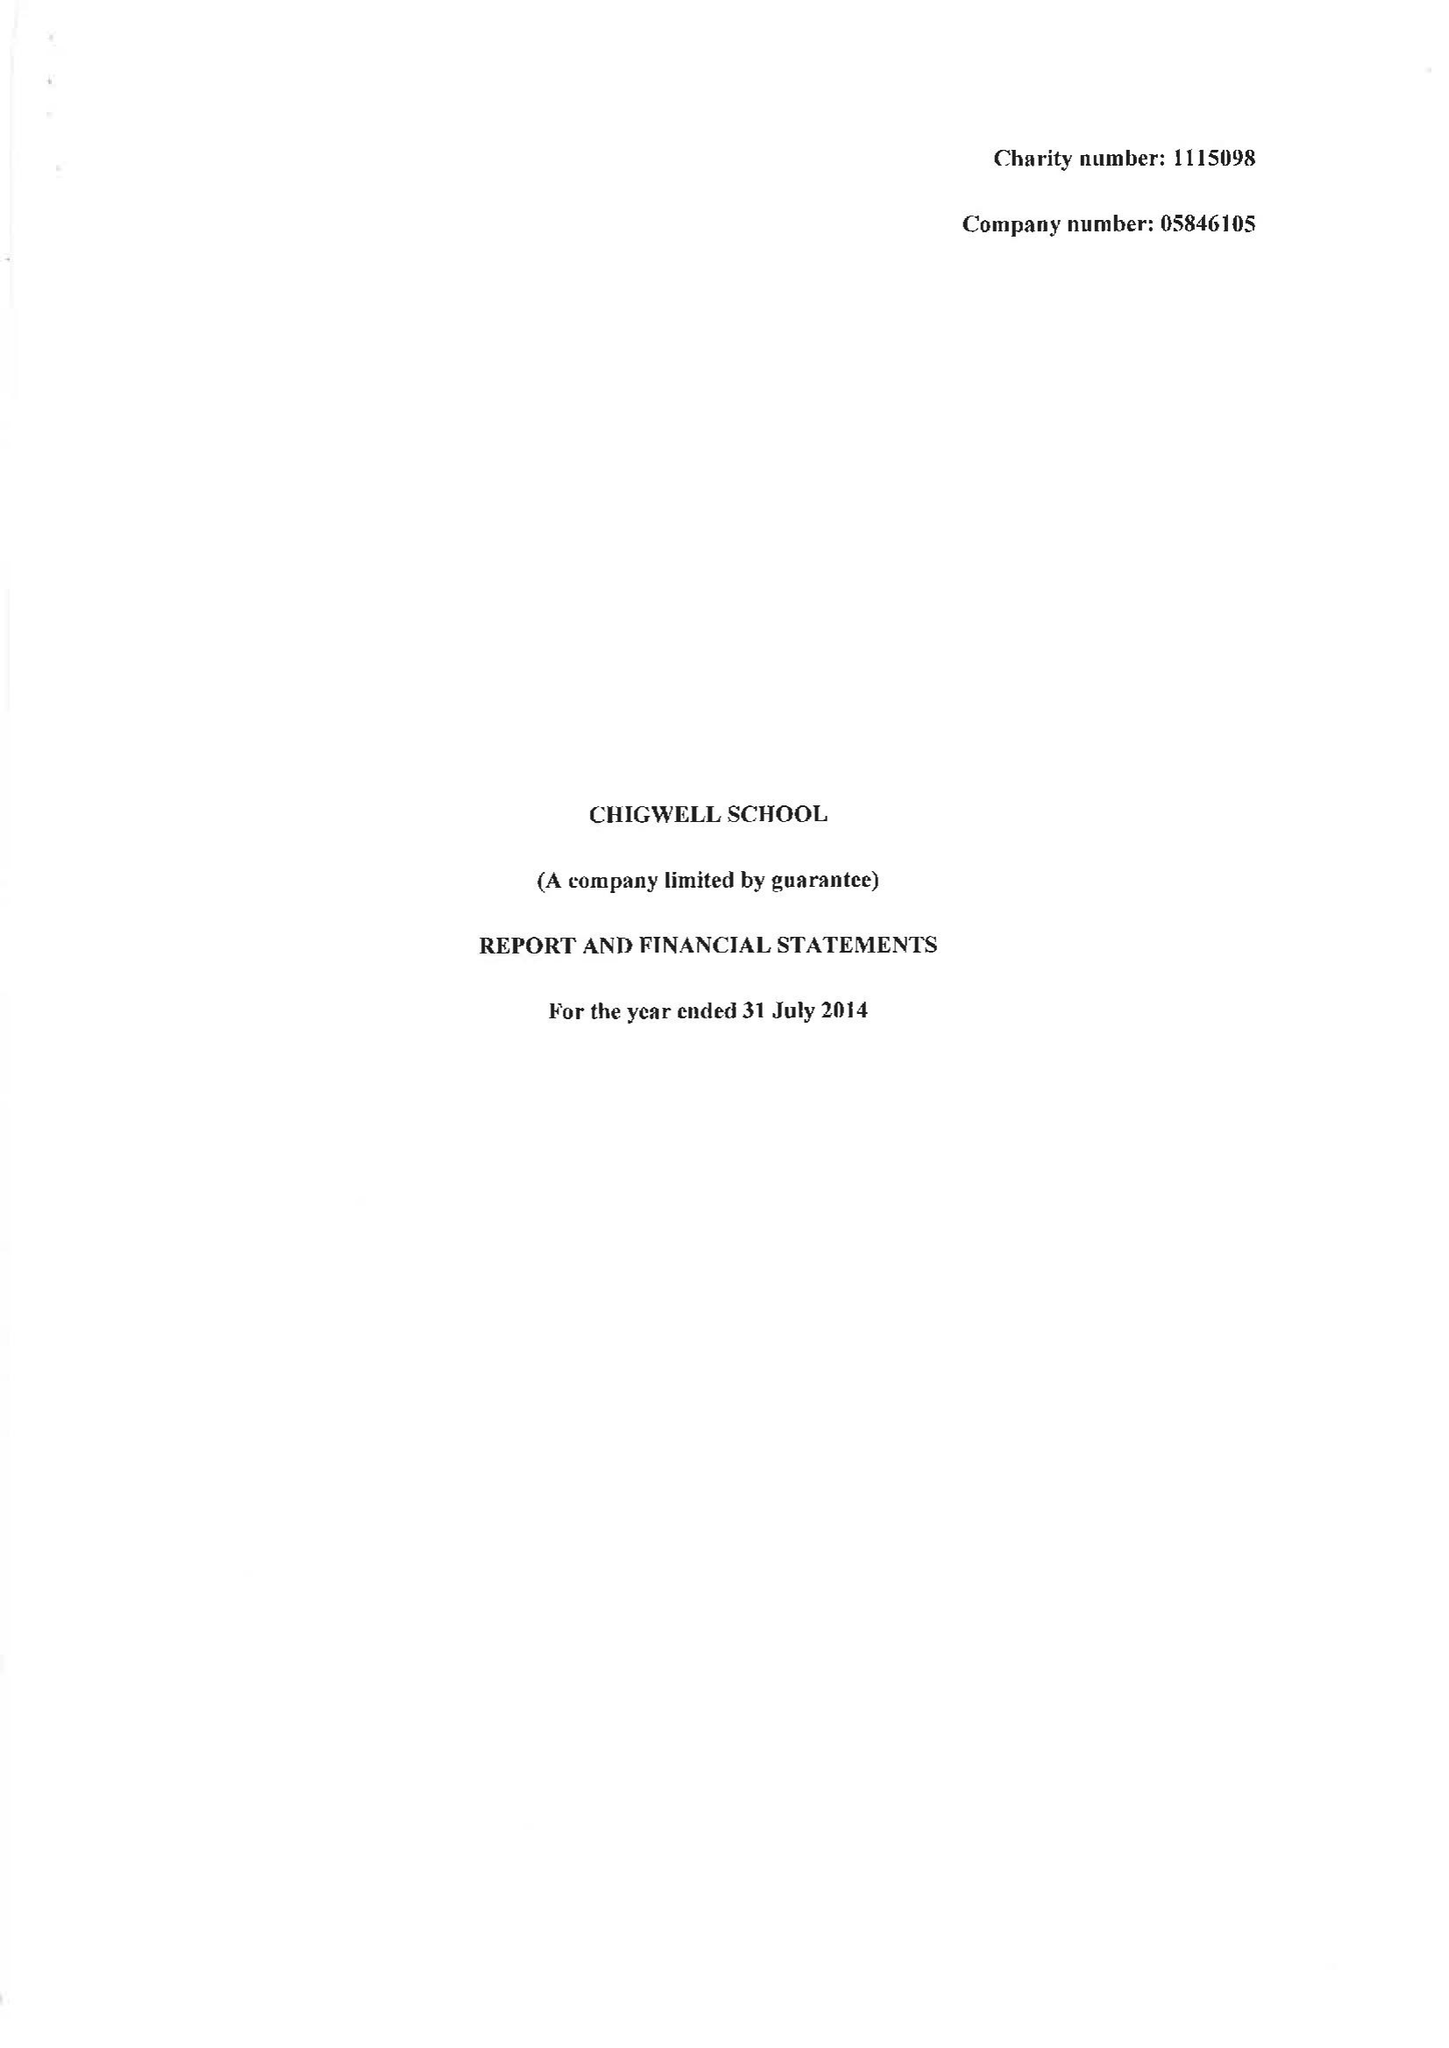What is the value for the income_annually_in_british_pounds?
Answer the question using a single word or phrase. 11946000.00 